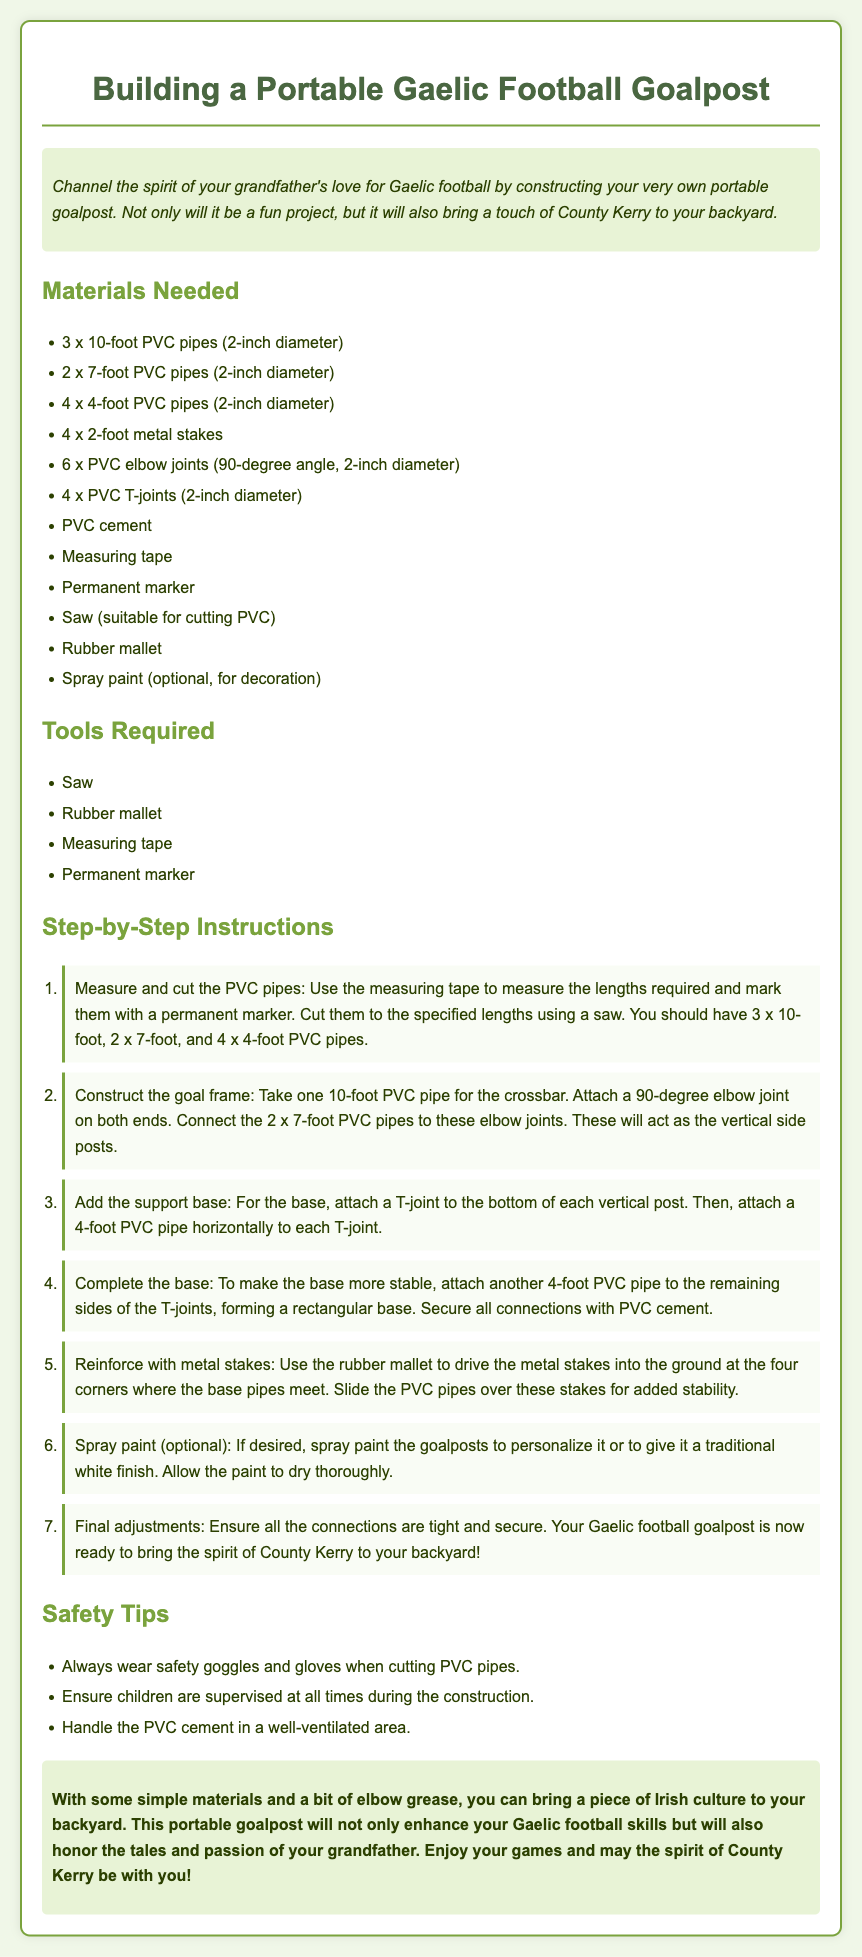what are the dimensions of the PVC pipes needed? The document lists three dimensions for the PVC pipes: 10-foot, 7-foot, and 4-foot.
Answer: 10-foot, 7-foot, 4-foot how many metal stakes are required? The assembly instructions specify the need for 4 x 2-foot metal stakes.
Answer: 4 what is the purpose of the T-joint in the construction? The T-joint is used to attach the vertical posts to the base pipes for added support.
Answer: Support base how should the goalpost be secured to the ground? The instructions recommend driving metal stakes into the ground and sliding PVC pipes over them.
Answer: Metal stakes what should you do before using the saw to cut PVC pipes? Safety tips advise wearing safety goggles and gloves when cutting PVC pipes.
Answer: Wear safety goggles and gloves how many PVC elbow joints are needed? The instructions require 6 x PVC elbow joints for the construction.
Answer: 6 what should be done to personalize the goalpost? The document suggests using spray paint to decorate the goalpost as an optional step.
Answer: Spray paint what is the final check before completing the goalpost? The final adjustment involves ensuring that all connections are tight and secure.
Answer: Tight and secure connections 